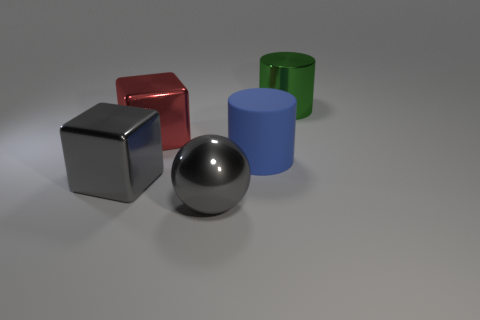Add 3 large blue shiny spheres. How many objects exist? 8 Subtract 1 cylinders. How many cylinders are left? 1 Subtract all gray cylinders. Subtract all brown cubes. How many cylinders are left? 2 Subtract all red cylinders. How many red cubes are left? 1 Subtract all large blue objects. Subtract all gray metallic spheres. How many objects are left? 3 Add 5 large blue things. How many large blue things are left? 6 Add 2 big green shiny objects. How many big green shiny objects exist? 3 Subtract 0 yellow cylinders. How many objects are left? 5 Subtract all cylinders. How many objects are left? 3 